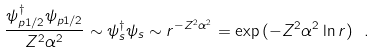Convert formula to latex. <formula><loc_0><loc_0><loc_500><loc_500>\frac { \psi _ { p 1 / 2 } ^ { \dagger } \psi _ { p 1 / 2 } } { Z ^ { 2 } \alpha ^ { 2 } } \sim \psi _ { s } ^ { \dagger } \psi _ { s } \sim r ^ { - Z ^ { 2 } \alpha ^ { 2 } } = \exp { ( - Z ^ { 2 } \alpha ^ { 2 } \ln r ) } \ .</formula> 